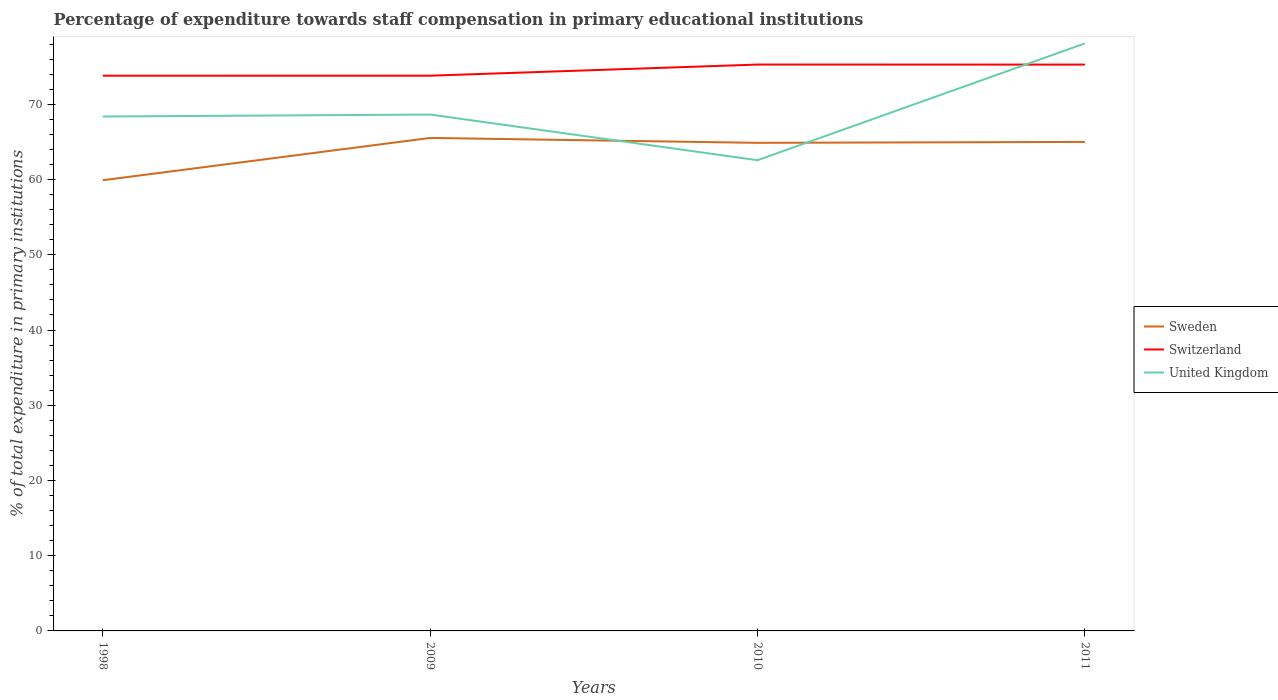How many different coloured lines are there?
Your response must be concise. 3. Does the line corresponding to Sweden intersect with the line corresponding to Switzerland?
Provide a succinct answer. No. Is the number of lines equal to the number of legend labels?
Your response must be concise. Yes. Across all years, what is the maximum percentage of expenditure towards staff compensation in Sweden?
Offer a very short reply. 59.92. What is the total percentage of expenditure towards staff compensation in United Kingdom in the graph?
Offer a very short reply. 6.07. What is the difference between the highest and the second highest percentage of expenditure towards staff compensation in United Kingdom?
Provide a short and direct response. 15.53. What is the difference between the highest and the lowest percentage of expenditure towards staff compensation in Sweden?
Provide a short and direct response. 3. Is the percentage of expenditure towards staff compensation in Sweden strictly greater than the percentage of expenditure towards staff compensation in Switzerland over the years?
Your answer should be very brief. Yes. Are the values on the major ticks of Y-axis written in scientific E-notation?
Give a very brief answer. No. How many legend labels are there?
Your answer should be very brief. 3. What is the title of the graph?
Provide a succinct answer. Percentage of expenditure towards staff compensation in primary educational institutions. What is the label or title of the Y-axis?
Ensure brevity in your answer.  % of total expenditure in primary institutions. What is the % of total expenditure in primary institutions in Sweden in 1998?
Make the answer very short. 59.92. What is the % of total expenditure in primary institutions in Switzerland in 1998?
Your answer should be very brief. 73.81. What is the % of total expenditure in primary institutions of United Kingdom in 1998?
Your answer should be very brief. 68.38. What is the % of total expenditure in primary institutions in Sweden in 2009?
Provide a succinct answer. 65.54. What is the % of total expenditure in primary institutions of Switzerland in 2009?
Your answer should be very brief. 73.81. What is the % of total expenditure in primary institutions of United Kingdom in 2009?
Give a very brief answer. 68.65. What is the % of total expenditure in primary institutions of Sweden in 2010?
Your response must be concise. 64.88. What is the % of total expenditure in primary institutions of Switzerland in 2010?
Offer a terse response. 75.29. What is the % of total expenditure in primary institutions in United Kingdom in 2010?
Make the answer very short. 62.58. What is the % of total expenditure in primary institutions in Sweden in 2011?
Provide a short and direct response. 65.01. What is the % of total expenditure in primary institutions in Switzerland in 2011?
Your response must be concise. 75.29. What is the % of total expenditure in primary institutions of United Kingdom in 2011?
Make the answer very short. 78.1. Across all years, what is the maximum % of total expenditure in primary institutions of Sweden?
Keep it short and to the point. 65.54. Across all years, what is the maximum % of total expenditure in primary institutions of Switzerland?
Your answer should be compact. 75.29. Across all years, what is the maximum % of total expenditure in primary institutions in United Kingdom?
Offer a terse response. 78.1. Across all years, what is the minimum % of total expenditure in primary institutions of Sweden?
Your response must be concise. 59.92. Across all years, what is the minimum % of total expenditure in primary institutions in Switzerland?
Offer a terse response. 73.81. Across all years, what is the minimum % of total expenditure in primary institutions of United Kingdom?
Keep it short and to the point. 62.58. What is the total % of total expenditure in primary institutions in Sweden in the graph?
Your response must be concise. 255.35. What is the total % of total expenditure in primary institutions of Switzerland in the graph?
Offer a very short reply. 298.2. What is the total % of total expenditure in primary institutions of United Kingdom in the graph?
Provide a succinct answer. 277.71. What is the difference between the % of total expenditure in primary institutions in Sweden in 1998 and that in 2009?
Give a very brief answer. -5.62. What is the difference between the % of total expenditure in primary institutions in Switzerland in 1998 and that in 2009?
Ensure brevity in your answer.  -0. What is the difference between the % of total expenditure in primary institutions of United Kingdom in 1998 and that in 2009?
Provide a succinct answer. -0.26. What is the difference between the % of total expenditure in primary institutions in Sweden in 1998 and that in 2010?
Your response must be concise. -4.97. What is the difference between the % of total expenditure in primary institutions in Switzerland in 1998 and that in 2010?
Provide a succinct answer. -1.48. What is the difference between the % of total expenditure in primary institutions in United Kingdom in 1998 and that in 2010?
Keep it short and to the point. 5.81. What is the difference between the % of total expenditure in primary institutions in Sweden in 1998 and that in 2011?
Ensure brevity in your answer.  -5.09. What is the difference between the % of total expenditure in primary institutions of Switzerland in 1998 and that in 2011?
Provide a short and direct response. -1.48. What is the difference between the % of total expenditure in primary institutions of United Kingdom in 1998 and that in 2011?
Provide a succinct answer. -9.72. What is the difference between the % of total expenditure in primary institutions in Sweden in 2009 and that in 2010?
Your response must be concise. 0.65. What is the difference between the % of total expenditure in primary institutions of Switzerland in 2009 and that in 2010?
Keep it short and to the point. -1.48. What is the difference between the % of total expenditure in primary institutions of United Kingdom in 2009 and that in 2010?
Your answer should be very brief. 6.07. What is the difference between the % of total expenditure in primary institutions of Sweden in 2009 and that in 2011?
Offer a terse response. 0.53. What is the difference between the % of total expenditure in primary institutions of Switzerland in 2009 and that in 2011?
Provide a succinct answer. -1.48. What is the difference between the % of total expenditure in primary institutions in United Kingdom in 2009 and that in 2011?
Ensure brevity in your answer.  -9.46. What is the difference between the % of total expenditure in primary institutions in Sweden in 2010 and that in 2011?
Ensure brevity in your answer.  -0.13. What is the difference between the % of total expenditure in primary institutions in Switzerland in 2010 and that in 2011?
Make the answer very short. 0. What is the difference between the % of total expenditure in primary institutions in United Kingdom in 2010 and that in 2011?
Make the answer very short. -15.53. What is the difference between the % of total expenditure in primary institutions in Sweden in 1998 and the % of total expenditure in primary institutions in Switzerland in 2009?
Keep it short and to the point. -13.9. What is the difference between the % of total expenditure in primary institutions in Sweden in 1998 and the % of total expenditure in primary institutions in United Kingdom in 2009?
Provide a short and direct response. -8.73. What is the difference between the % of total expenditure in primary institutions in Switzerland in 1998 and the % of total expenditure in primary institutions in United Kingdom in 2009?
Ensure brevity in your answer.  5.16. What is the difference between the % of total expenditure in primary institutions of Sweden in 1998 and the % of total expenditure in primary institutions of Switzerland in 2010?
Your answer should be compact. -15.38. What is the difference between the % of total expenditure in primary institutions of Sweden in 1998 and the % of total expenditure in primary institutions of United Kingdom in 2010?
Your response must be concise. -2.66. What is the difference between the % of total expenditure in primary institutions in Switzerland in 1998 and the % of total expenditure in primary institutions in United Kingdom in 2010?
Provide a short and direct response. 11.23. What is the difference between the % of total expenditure in primary institutions in Sweden in 1998 and the % of total expenditure in primary institutions in Switzerland in 2011?
Ensure brevity in your answer.  -15.37. What is the difference between the % of total expenditure in primary institutions of Sweden in 1998 and the % of total expenditure in primary institutions of United Kingdom in 2011?
Your response must be concise. -18.19. What is the difference between the % of total expenditure in primary institutions in Switzerland in 1998 and the % of total expenditure in primary institutions in United Kingdom in 2011?
Your answer should be compact. -4.29. What is the difference between the % of total expenditure in primary institutions of Sweden in 2009 and the % of total expenditure in primary institutions of Switzerland in 2010?
Give a very brief answer. -9.75. What is the difference between the % of total expenditure in primary institutions in Sweden in 2009 and the % of total expenditure in primary institutions in United Kingdom in 2010?
Your response must be concise. 2.96. What is the difference between the % of total expenditure in primary institutions in Switzerland in 2009 and the % of total expenditure in primary institutions in United Kingdom in 2010?
Make the answer very short. 11.24. What is the difference between the % of total expenditure in primary institutions in Sweden in 2009 and the % of total expenditure in primary institutions in Switzerland in 2011?
Your answer should be compact. -9.75. What is the difference between the % of total expenditure in primary institutions of Sweden in 2009 and the % of total expenditure in primary institutions of United Kingdom in 2011?
Keep it short and to the point. -12.56. What is the difference between the % of total expenditure in primary institutions in Switzerland in 2009 and the % of total expenditure in primary institutions in United Kingdom in 2011?
Provide a succinct answer. -4.29. What is the difference between the % of total expenditure in primary institutions in Sweden in 2010 and the % of total expenditure in primary institutions in Switzerland in 2011?
Give a very brief answer. -10.4. What is the difference between the % of total expenditure in primary institutions in Sweden in 2010 and the % of total expenditure in primary institutions in United Kingdom in 2011?
Offer a very short reply. -13.22. What is the difference between the % of total expenditure in primary institutions of Switzerland in 2010 and the % of total expenditure in primary institutions of United Kingdom in 2011?
Your answer should be very brief. -2.81. What is the average % of total expenditure in primary institutions in Sweden per year?
Your answer should be very brief. 63.84. What is the average % of total expenditure in primary institutions of Switzerland per year?
Keep it short and to the point. 74.55. What is the average % of total expenditure in primary institutions of United Kingdom per year?
Your response must be concise. 69.43. In the year 1998, what is the difference between the % of total expenditure in primary institutions in Sweden and % of total expenditure in primary institutions in Switzerland?
Ensure brevity in your answer.  -13.89. In the year 1998, what is the difference between the % of total expenditure in primary institutions in Sweden and % of total expenditure in primary institutions in United Kingdom?
Give a very brief answer. -8.47. In the year 1998, what is the difference between the % of total expenditure in primary institutions in Switzerland and % of total expenditure in primary institutions in United Kingdom?
Ensure brevity in your answer.  5.42. In the year 2009, what is the difference between the % of total expenditure in primary institutions in Sweden and % of total expenditure in primary institutions in Switzerland?
Keep it short and to the point. -8.27. In the year 2009, what is the difference between the % of total expenditure in primary institutions of Sweden and % of total expenditure in primary institutions of United Kingdom?
Offer a terse response. -3.11. In the year 2009, what is the difference between the % of total expenditure in primary institutions of Switzerland and % of total expenditure in primary institutions of United Kingdom?
Ensure brevity in your answer.  5.17. In the year 2010, what is the difference between the % of total expenditure in primary institutions of Sweden and % of total expenditure in primary institutions of Switzerland?
Provide a succinct answer. -10.41. In the year 2010, what is the difference between the % of total expenditure in primary institutions in Sweden and % of total expenditure in primary institutions in United Kingdom?
Offer a terse response. 2.31. In the year 2010, what is the difference between the % of total expenditure in primary institutions in Switzerland and % of total expenditure in primary institutions in United Kingdom?
Make the answer very short. 12.72. In the year 2011, what is the difference between the % of total expenditure in primary institutions of Sweden and % of total expenditure in primary institutions of Switzerland?
Offer a very short reply. -10.28. In the year 2011, what is the difference between the % of total expenditure in primary institutions of Sweden and % of total expenditure in primary institutions of United Kingdom?
Make the answer very short. -13.09. In the year 2011, what is the difference between the % of total expenditure in primary institutions of Switzerland and % of total expenditure in primary institutions of United Kingdom?
Offer a terse response. -2.81. What is the ratio of the % of total expenditure in primary institutions of Sweden in 1998 to that in 2009?
Your answer should be very brief. 0.91. What is the ratio of the % of total expenditure in primary institutions of Switzerland in 1998 to that in 2009?
Make the answer very short. 1. What is the ratio of the % of total expenditure in primary institutions of United Kingdom in 1998 to that in 2009?
Provide a short and direct response. 1. What is the ratio of the % of total expenditure in primary institutions of Sweden in 1998 to that in 2010?
Your answer should be compact. 0.92. What is the ratio of the % of total expenditure in primary institutions in Switzerland in 1998 to that in 2010?
Ensure brevity in your answer.  0.98. What is the ratio of the % of total expenditure in primary institutions in United Kingdom in 1998 to that in 2010?
Give a very brief answer. 1.09. What is the ratio of the % of total expenditure in primary institutions of Sweden in 1998 to that in 2011?
Provide a short and direct response. 0.92. What is the ratio of the % of total expenditure in primary institutions in Switzerland in 1998 to that in 2011?
Your answer should be compact. 0.98. What is the ratio of the % of total expenditure in primary institutions of United Kingdom in 1998 to that in 2011?
Offer a terse response. 0.88. What is the ratio of the % of total expenditure in primary institutions in Switzerland in 2009 to that in 2010?
Give a very brief answer. 0.98. What is the ratio of the % of total expenditure in primary institutions of United Kingdom in 2009 to that in 2010?
Provide a succinct answer. 1.1. What is the ratio of the % of total expenditure in primary institutions in Sweden in 2009 to that in 2011?
Offer a very short reply. 1.01. What is the ratio of the % of total expenditure in primary institutions of Switzerland in 2009 to that in 2011?
Provide a short and direct response. 0.98. What is the ratio of the % of total expenditure in primary institutions in United Kingdom in 2009 to that in 2011?
Provide a short and direct response. 0.88. What is the ratio of the % of total expenditure in primary institutions of Sweden in 2010 to that in 2011?
Offer a terse response. 1. What is the ratio of the % of total expenditure in primary institutions in Switzerland in 2010 to that in 2011?
Your response must be concise. 1. What is the ratio of the % of total expenditure in primary institutions of United Kingdom in 2010 to that in 2011?
Provide a short and direct response. 0.8. What is the difference between the highest and the second highest % of total expenditure in primary institutions of Sweden?
Offer a terse response. 0.53. What is the difference between the highest and the second highest % of total expenditure in primary institutions in Switzerland?
Offer a very short reply. 0. What is the difference between the highest and the second highest % of total expenditure in primary institutions of United Kingdom?
Ensure brevity in your answer.  9.46. What is the difference between the highest and the lowest % of total expenditure in primary institutions of Sweden?
Your answer should be compact. 5.62. What is the difference between the highest and the lowest % of total expenditure in primary institutions of Switzerland?
Provide a short and direct response. 1.48. What is the difference between the highest and the lowest % of total expenditure in primary institutions in United Kingdom?
Make the answer very short. 15.53. 